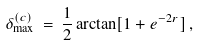Convert formula to latex. <formula><loc_0><loc_0><loc_500><loc_500>\delta _ { \max } ^ { ( c ) } \, = \, \frac { 1 } { 2 } \arctan [ 1 + e ^ { - 2 r } ] \, ,</formula> 